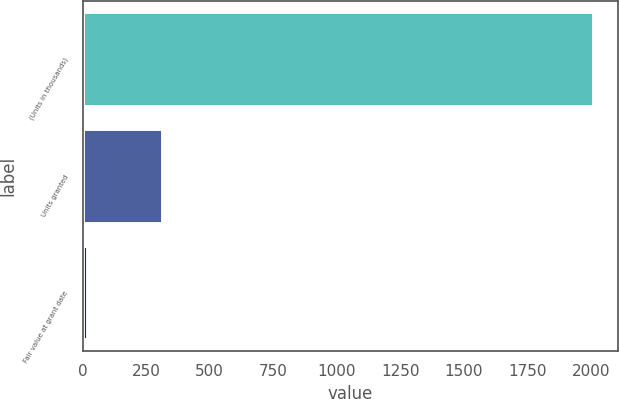<chart> <loc_0><loc_0><loc_500><loc_500><bar_chart><fcel>(Units in thousands)<fcel>Units granted<fcel>Fair value at grant date<nl><fcel>2007<fcel>313<fcel>19.08<nl></chart> 